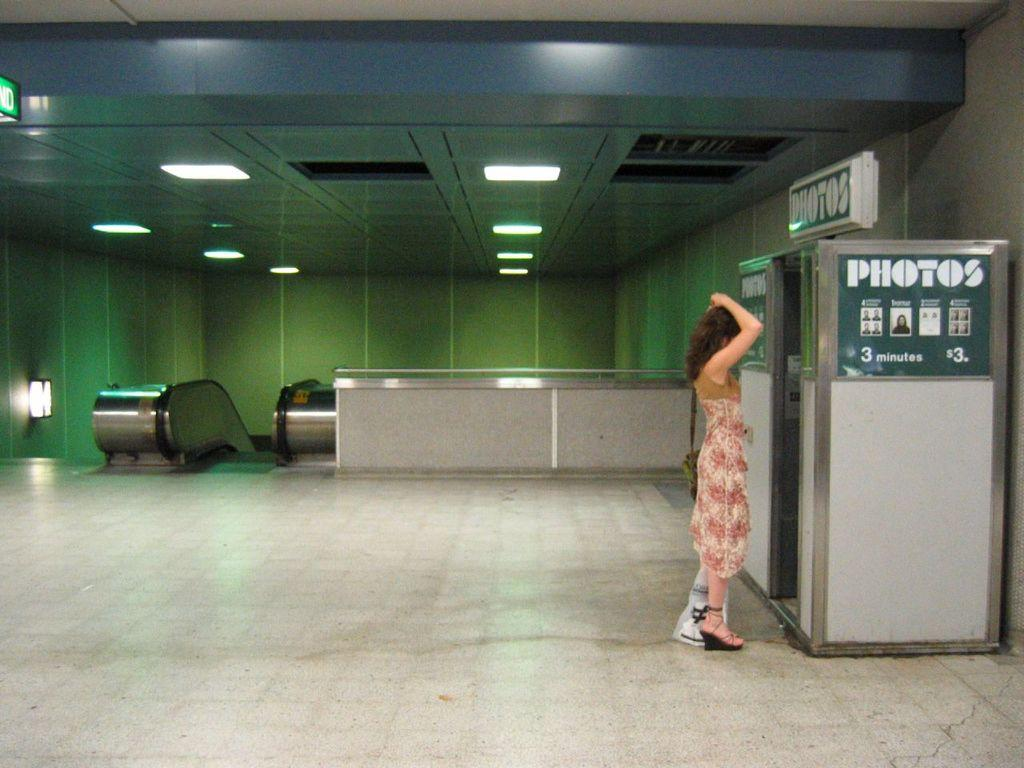Who is the main subject in the image? There is a lady standing in the image. Where is the lady positioned in the image? The lady is on the right side of the image. What is the lady standing in front of? The lady is standing in front of a photo booth. What can be seen in the background of the image? There is an escalator, a railing, and a light in the background of the image. What type of fowl can be seen walking on the escalator in the image? There is no fowl present in the image, and the escalator is not a separate image but a part of the background. 